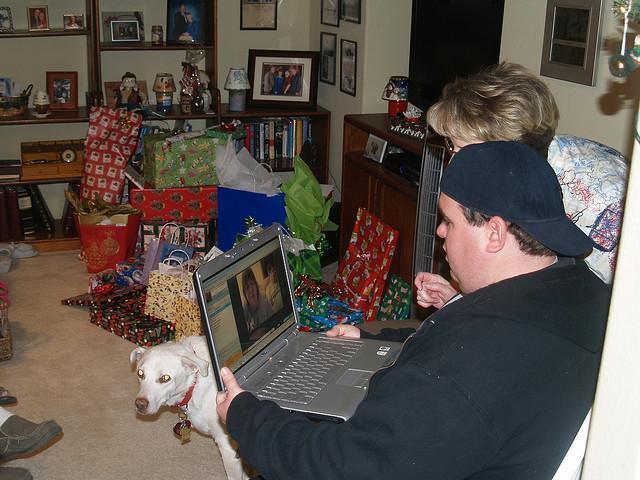How many people are there?
Give a very brief answer. 3. How many cars are there?
Give a very brief answer. 0. 